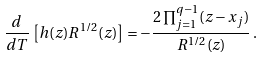<formula> <loc_0><loc_0><loc_500><loc_500>\frac { d } { d T } \, \left [ h ( z ) R ^ { 1 / 2 } ( z ) \right ] = - \frac { 2 \prod _ { j = 1 } ^ { q - 1 } ( z - x _ { j } ) } { R ^ { 1 / 2 } ( z ) } \, .</formula> 